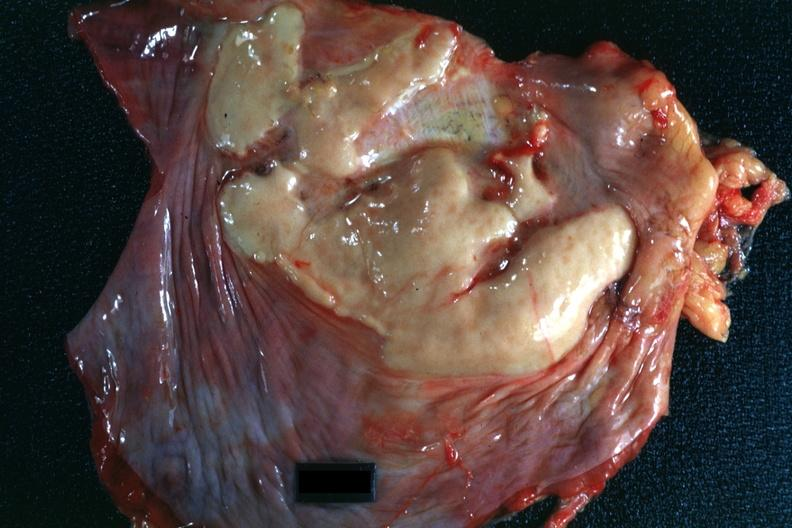what is present?
Answer the question using a single word or phrase. Muscle 